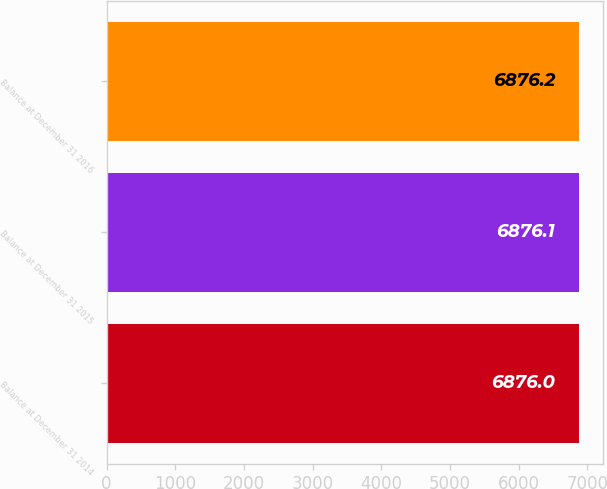Convert chart. <chart><loc_0><loc_0><loc_500><loc_500><bar_chart><fcel>Balance at December 31 2014<fcel>Balance at December 31 2015<fcel>Balance at December 31 2016<nl><fcel>6876<fcel>6876.1<fcel>6876.2<nl></chart> 